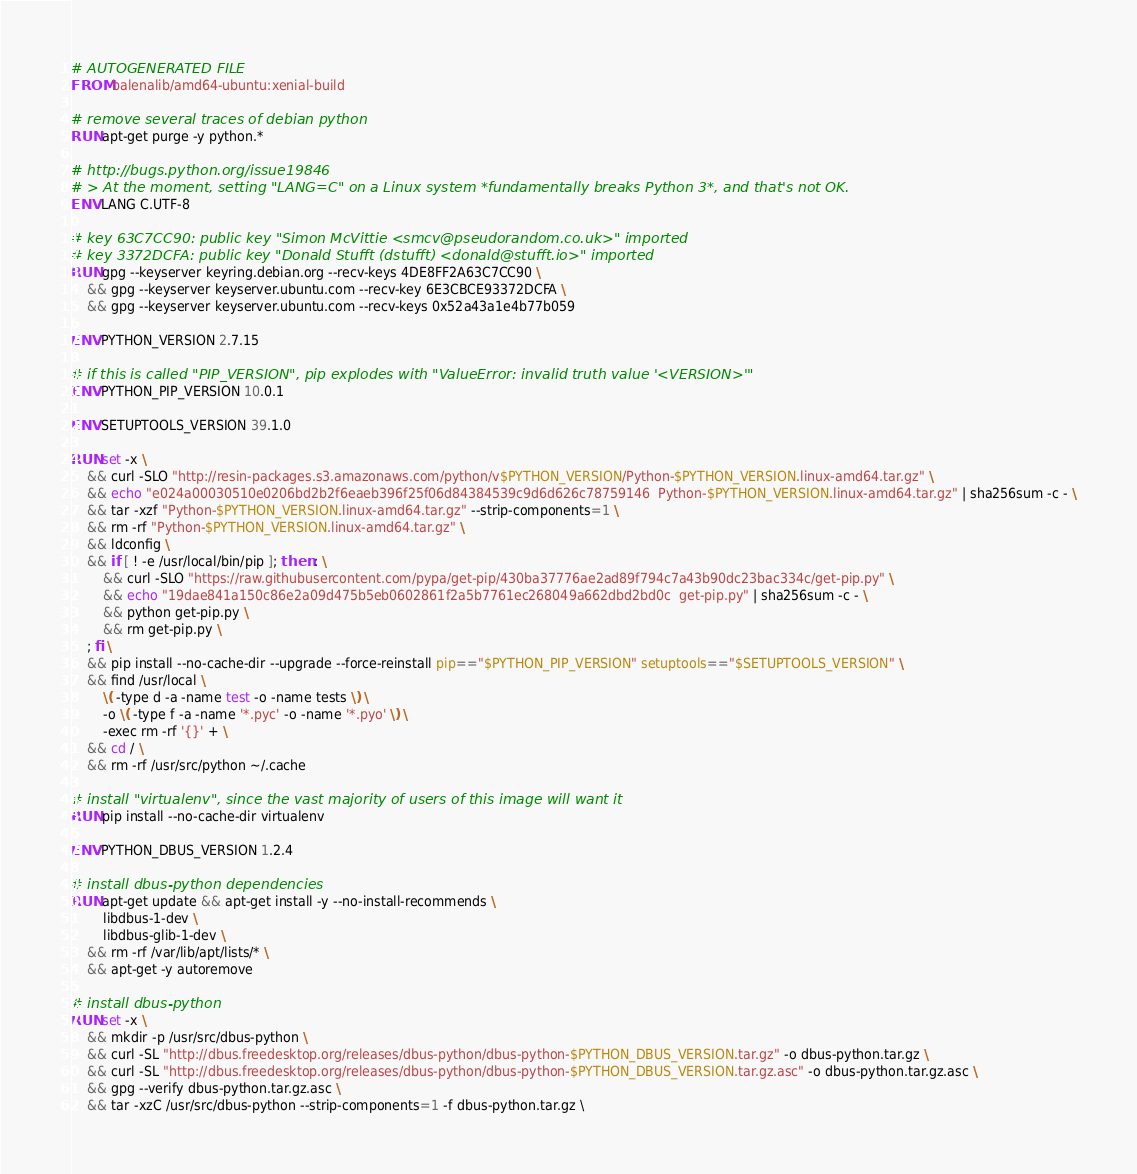Convert code to text. <code><loc_0><loc_0><loc_500><loc_500><_Dockerfile_># AUTOGENERATED FILE
FROM balenalib/amd64-ubuntu:xenial-build

# remove several traces of debian python
RUN apt-get purge -y python.*

# http://bugs.python.org/issue19846
# > At the moment, setting "LANG=C" on a Linux system *fundamentally breaks Python 3*, and that's not OK.
ENV LANG C.UTF-8

# key 63C7CC90: public key "Simon McVittie <smcv@pseudorandom.co.uk>" imported
# key 3372DCFA: public key "Donald Stufft (dstufft) <donald@stufft.io>" imported
RUN gpg --keyserver keyring.debian.org --recv-keys 4DE8FF2A63C7CC90 \
	&& gpg --keyserver keyserver.ubuntu.com --recv-key 6E3CBCE93372DCFA \
	&& gpg --keyserver keyserver.ubuntu.com --recv-keys 0x52a43a1e4b77b059

ENV PYTHON_VERSION 2.7.15

# if this is called "PIP_VERSION", pip explodes with "ValueError: invalid truth value '<VERSION>'"
ENV PYTHON_PIP_VERSION 10.0.1

ENV SETUPTOOLS_VERSION 39.1.0

RUN set -x \
	&& curl -SLO "http://resin-packages.s3.amazonaws.com/python/v$PYTHON_VERSION/Python-$PYTHON_VERSION.linux-amd64.tar.gz" \
	&& echo "e024a00030510e0206bd2b2f6eaeb396f25f06d84384539c9d6d626c78759146  Python-$PYTHON_VERSION.linux-amd64.tar.gz" | sha256sum -c - \
	&& tar -xzf "Python-$PYTHON_VERSION.linux-amd64.tar.gz" --strip-components=1 \
	&& rm -rf "Python-$PYTHON_VERSION.linux-amd64.tar.gz" \
	&& ldconfig \
	&& if [ ! -e /usr/local/bin/pip ]; then : \
		&& curl -SLO "https://raw.githubusercontent.com/pypa/get-pip/430ba37776ae2ad89f794c7a43b90dc23bac334c/get-pip.py" \
		&& echo "19dae841a150c86e2a09d475b5eb0602861f2a5b7761ec268049a662dbd2bd0c  get-pip.py" | sha256sum -c - \
		&& python get-pip.py \
		&& rm get-pip.py \
	; fi \
	&& pip install --no-cache-dir --upgrade --force-reinstall pip=="$PYTHON_PIP_VERSION" setuptools=="$SETUPTOOLS_VERSION" \
	&& find /usr/local \
		\( -type d -a -name test -o -name tests \) \
		-o \( -type f -a -name '*.pyc' -o -name '*.pyo' \) \
		-exec rm -rf '{}' + \
	&& cd / \
	&& rm -rf /usr/src/python ~/.cache

# install "virtualenv", since the vast majority of users of this image will want it
RUN pip install --no-cache-dir virtualenv

ENV PYTHON_DBUS_VERSION 1.2.4

# install dbus-python dependencies 
RUN apt-get update && apt-get install -y --no-install-recommends \
		libdbus-1-dev \
		libdbus-glib-1-dev \
	&& rm -rf /var/lib/apt/lists/* \
	&& apt-get -y autoremove

# install dbus-python
RUN set -x \
	&& mkdir -p /usr/src/dbus-python \
	&& curl -SL "http://dbus.freedesktop.org/releases/dbus-python/dbus-python-$PYTHON_DBUS_VERSION.tar.gz" -o dbus-python.tar.gz \
	&& curl -SL "http://dbus.freedesktop.org/releases/dbus-python/dbus-python-$PYTHON_DBUS_VERSION.tar.gz.asc" -o dbus-python.tar.gz.asc \
	&& gpg --verify dbus-python.tar.gz.asc \
	&& tar -xzC /usr/src/dbus-python --strip-components=1 -f dbus-python.tar.gz \</code> 